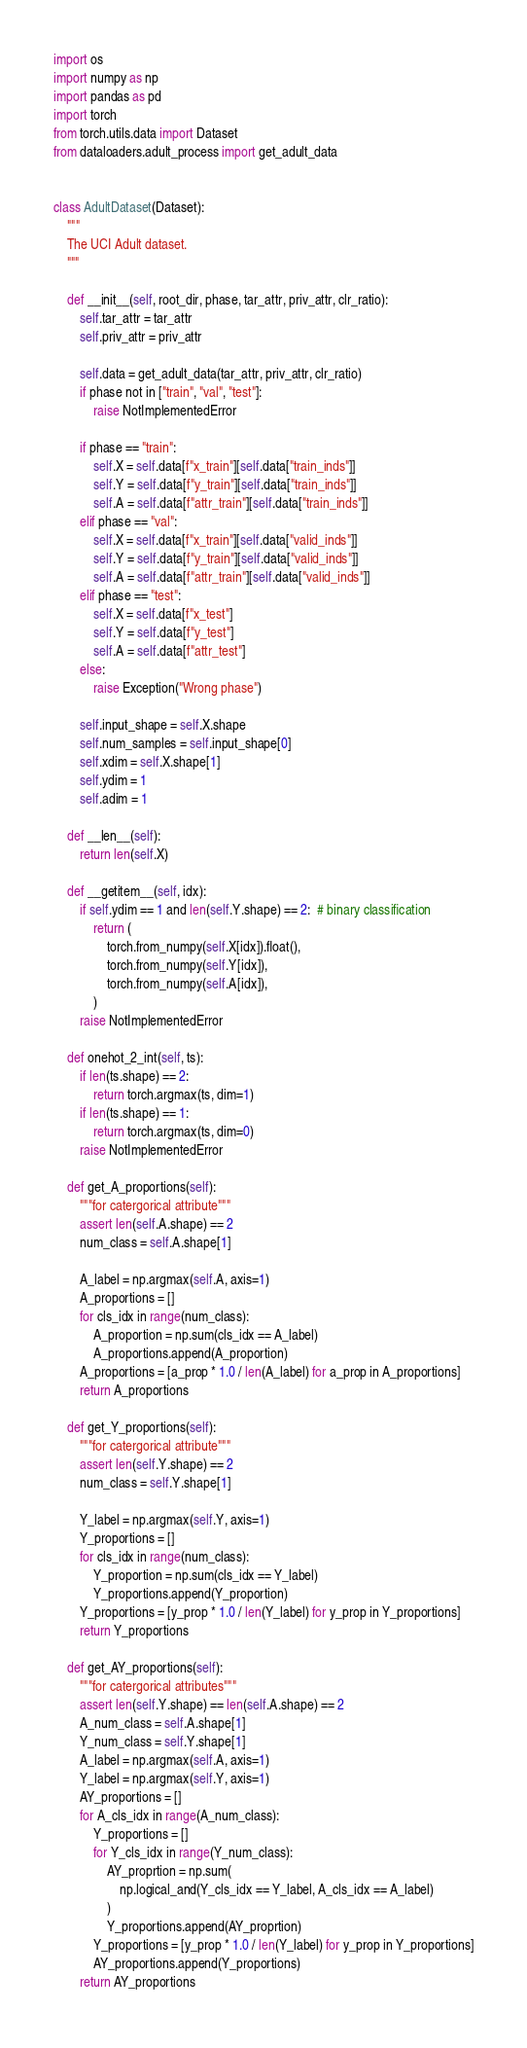Convert code to text. <code><loc_0><loc_0><loc_500><loc_500><_Python_>import os
import numpy as np
import pandas as pd
import torch
from torch.utils.data import Dataset
from dataloaders.adult_process import get_adult_data


class AdultDataset(Dataset):
    """
    The UCI Adult dataset.
    """

    def __init__(self, root_dir, phase, tar_attr, priv_attr, clr_ratio):
        self.tar_attr = tar_attr
        self.priv_attr = priv_attr

        self.data = get_adult_data(tar_attr, priv_attr, clr_ratio)
        if phase not in ["train", "val", "test"]:
            raise NotImplementedError

        if phase == "train":
            self.X = self.data[f"x_train"][self.data["train_inds"]]
            self.Y = self.data[f"y_train"][self.data["train_inds"]]
            self.A = self.data[f"attr_train"][self.data["train_inds"]]
        elif phase == "val":
            self.X = self.data[f"x_train"][self.data["valid_inds"]]
            self.Y = self.data[f"y_train"][self.data["valid_inds"]]
            self.A = self.data[f"attr_train"][self.data["valid_inds"]]
        elif phase == "test":
            self.X = self.data[f"x_test"]
            self.Y = self.data[f"y_test"]
            self.A = self.data[f"attr_test"]
        else:
            raise Exception("Wrong phase")

        self.input_shape = self.X.shape
        self.num_samples = self.input_shape[0]
        self.xdim = self.X.shape[1]
        self.ydim = 1
        self.adim = 1

    def __len__(self):
        return len(self.X)

    def __getitem__(self, idx):
        if self.ydim == 1 and len(self.Y.shape) == 2:  # binary classification
            return (
                torch.from_numpy(self.X[idx]).float(),
                torch.from_numpy(self.Y[idx]),
                torch.from_numpy(self.A[idx]),
            )
        raise NotImplementedError

    def onehot_2_int(self, ts):
        if len(ts.shape) == 2:
            return torch.argmax(ts, dim=1)
        if len(ts.shape) == 1:
            return torch.argmax(ts, dim=0)
        raise NotImplementedError

    def get_A_proportions(self):
        """for catergorical attribute"""
        assert len(self.A.shape) == 2
        num_class = self.A.shape[1]

        A_label = np.argmax(self.A, axis=1)
        A_proportions = []
        for cls_idx in range(num_class):
            A_proportion = np.sum(cls_idx == A_label)
            A_proportions.append(A_proportion)
        A_proportions = [a_prop * 1.0 / len(A_label) for a_prop in A_proportions]
        return A_proportions

    def get_Y_proportions(self):
        """for catergorical attribute"""
        assert len(self.Y.shape) == 2
        num_class = self.Y.shape[1]

        Y_label = np.argmax(self.Y, axis=1)
        Y_proportions = []
        for cls_idx in range(num_class):
            Y_proportion = np.sum(cls_idx == Y_label)
            Y_proportions.append(Y_proportion)
        Y_proportions = [y_prop * 1.0 / len(Y_label) for y_prop in Y_proportions]
        return Y_proportions

    def get_AY_proportions(self):
        """for catergorical attributes"""
        assert len(self.Y.shape) == len(self.A.shape) == 2
        A_num_class = self.A.shape[1]
        Y_num_class = self.Y.shape[1]
        A_label = np.argmax(self.A, axis=1)
        Y_label = np.argmax(self.Y, axis=1)
        AY_proportions = []
        for A_cls_idx in range(A_num_class):
            Y_proportions = []
            for Y_cls_idx in range(Y_num_class):
                AY_proprtion = np.sum(
                    np.logical_and(Y_cls_idx == Y_label, A_cls_idx == A_label)
                )
                Y_proportions.append(AY_proprtion)
            Y_proportions = [y_prop * 1.0 / len(Y_label) for y_prop in Y_proportions]
            AY_proportions.append(Y_proportions)
        return AY_proportions
</code> 